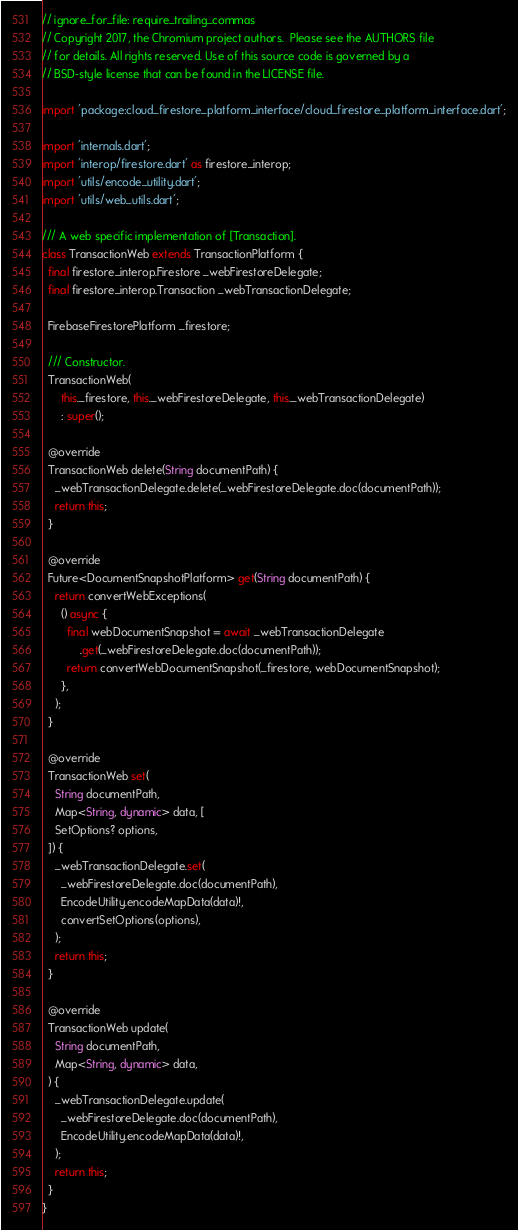Convert code to text. <code><loc_0><loc_0><loc_500><loc_500><_Dart_>// ignore_for_file: require_trailing_commas
// Copyright 2017, the Chromium project authors.  Please see the AUTHORS file
// for details. All rights reserved. Use of this source code is governed by a
// BSD-style license that can be found in the LICENSE file.

import 'package:cloud_firestore_platform_interface/cloud_firestore_platform_interface.dart';

import 'internals.dart';
import 'interop/firestore.dart' as firestore_interop;
import 'utils/encode_utility.dart';
import 'utils/web_utils.dart';

/// A web specific implementation of [Transaction].
class TransactionWeb extends TransactionPlatform {
  final firestore_interop.Firestore _webFirestoreDelegate;
  final firestore_interop.Transaction _webTransactionDelegate;

  FirebaseFirestorePlatform _firestore;

  /// Constructor.
  TransactionWeb(
      this._firestore, this._webFirestoreDelegate, this._webTransactionDelegate)
      : super();

  @override
  TransactionWeb delete(String documentPath) {
    _webTransactionDelegate.delete(_webFirestoreDelegate.doc(documentPath));
    return this;
  }

  @override
  Future<DocumentSnapshotPlatform> get(String documentPath) {
    return convertWebExceptions(
      () async {
        final webDocumentSnapshot = await _webTransactionDelegate
            .get(_webFirestoreDelegate.doc(documentPath));
        return convertWebDocumentSnapshot(_firestore, webDocumentSnapshot);
      },
    );
  }

  @override
  TransactionWeb set(
    String documentPath,
    Map<String, dynamic> data, [
    SetOptions? options,
  ]) {
    _webTransactionDelegate.set(
      _webFirestoreDelegate.doc(documentPath),
      EncodeUtility.encodeMapData(data)!,
      convertSetOptions(options),
    );
    return this;
  }

  @override
  TransactionWeb update(
    String documentPath,
    Map<String, dynamic> data,
  ) {
    _webTransactionDelegate.update(
      _webFirestoreDelegate.doc(documentPath),
      EncodeUtility.encodeMapData(data)!,
    );
    return this;
  }
}
</code> 